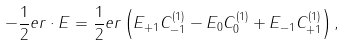<formula> <loc_0><loc_0><loc_500><loc_500>- \frac { 1 } { 2 } e r \cdot E = \frac { 1 } { 2 } e r \left ( E _ { + 1 } C _ { - 1 } ^ { ( 1 ) } - E _ { 0 } C _ { 0 } ^ { ( 1 ) } + E _ { - 1 } C _ { + 1 } ^ { ( 1 ) } \right ) ,</formula> 